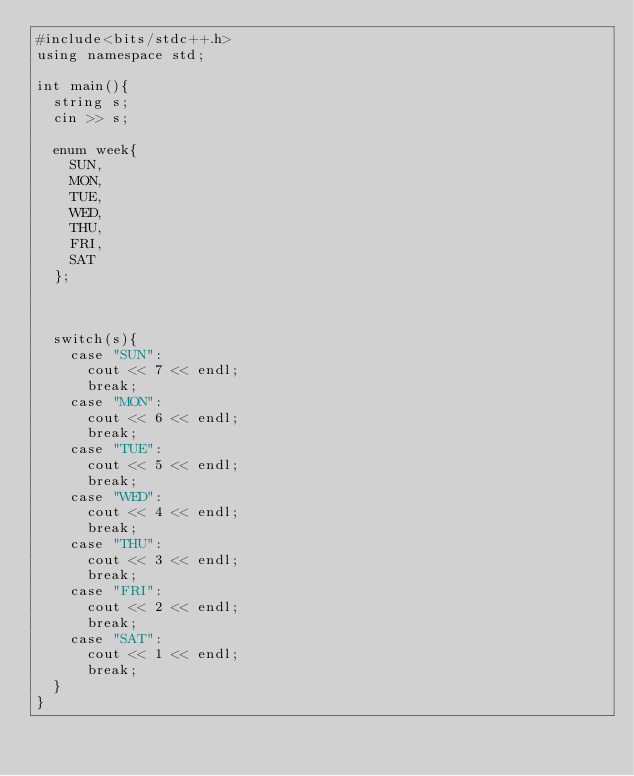Convert code to text. <code><loc_0><loc_0><loc_500><loc_500><_C++_>#include<bits/stdc++.h>
using namespace std;

int main(){
  string s;
  cin >> s;

  enum week{
    SUN,
    MON,
    TUE,
    WED,
    THU,
    FRI,
    SAT
  };

  

  switch(s){
    case "SUN":
      cout << 7 << endl;
      break;
    case "MON":
      cout << 6 << endl;
      break;
    case "TUE":
      cout << 5 << endl;
      break;
    case "WED":
      cout << 4 << endl;
      break;
    case "THU":
      cout << 3 << endl;
      break;
    case "FRI":
      cout << 2 << endl;
      break;
    case "SAT":
      cout << 1 << endl;
      break;
  }
}
</code> 